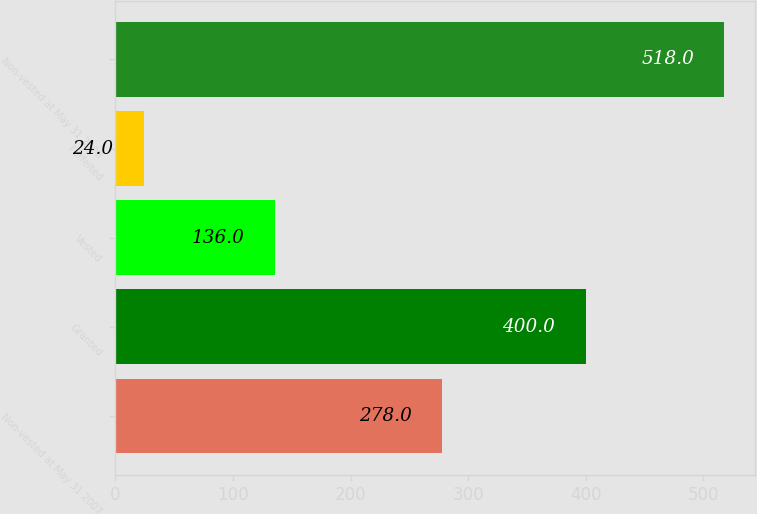Convert chart to OTSL. <chart><loc_0><loc_0><loc_500><loc_500><bar_chart><fcel>Non-vested at May 31 2007<fcel>Granted<fcel>Vested<fcel>Forfeited<fcel>Non-vested at May 31 2008<nl><fcel>278<fcel>400<fcel>136<fcel>24<fcel>518<nl></chart> 